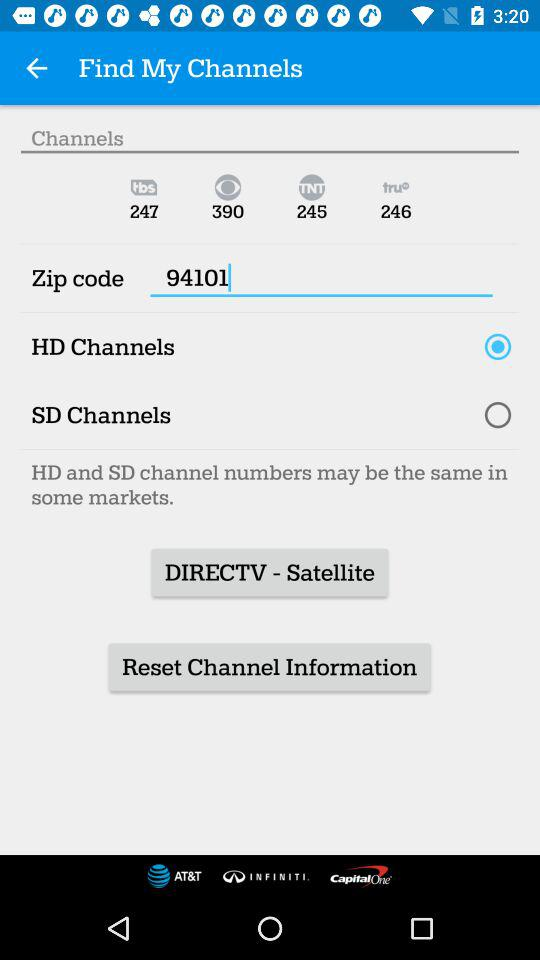What two channels are the same in the market? The HD and SD channels are the same in the market. 